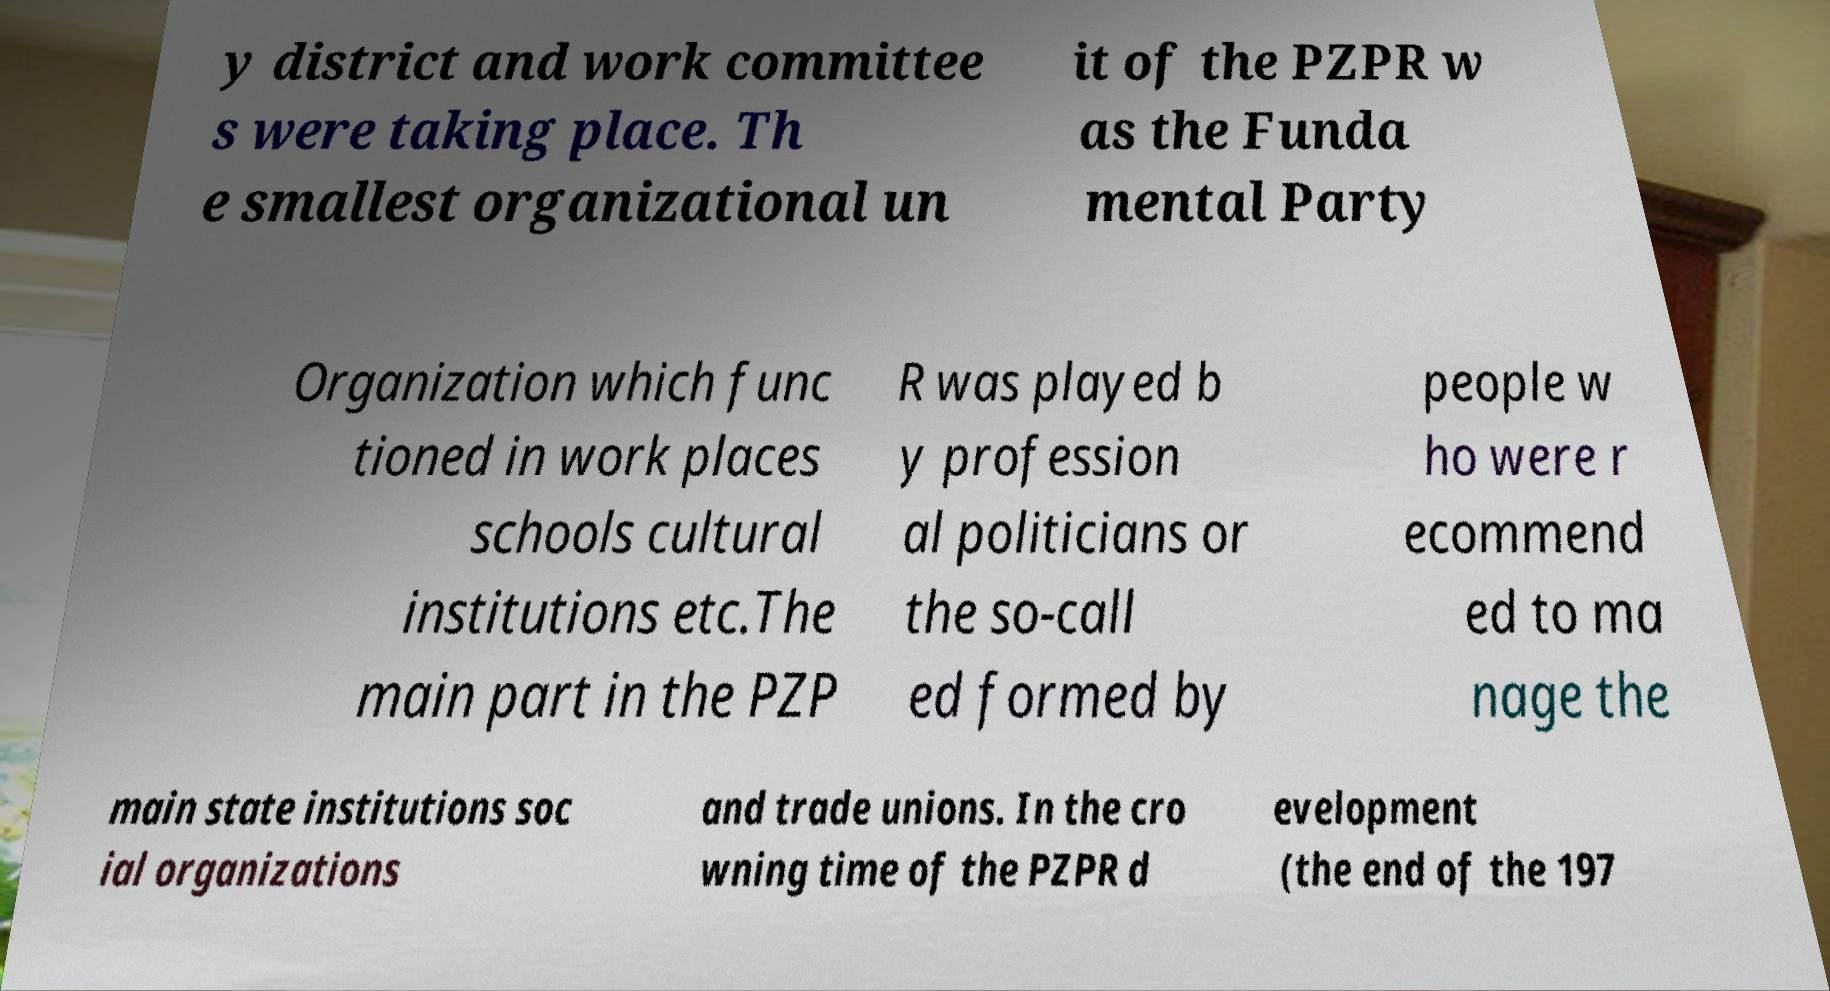For documentation purposes, I need the text within this image transcribed. Could you provide that? y district and work committee s were taking place. Th e smallest organizational un it of the PZPR w as the Funda mental Party Organization which func tioned in work places schools cultural institutions etc.The main part in the PZP R was played b y profession al politicians or the so-call ed formed by people w ho were r ecommend ed to ma nage the main state institutions soc ial organizations and trade unions. In the cro wning time of the PZPR d evelopment (the end of the 197 